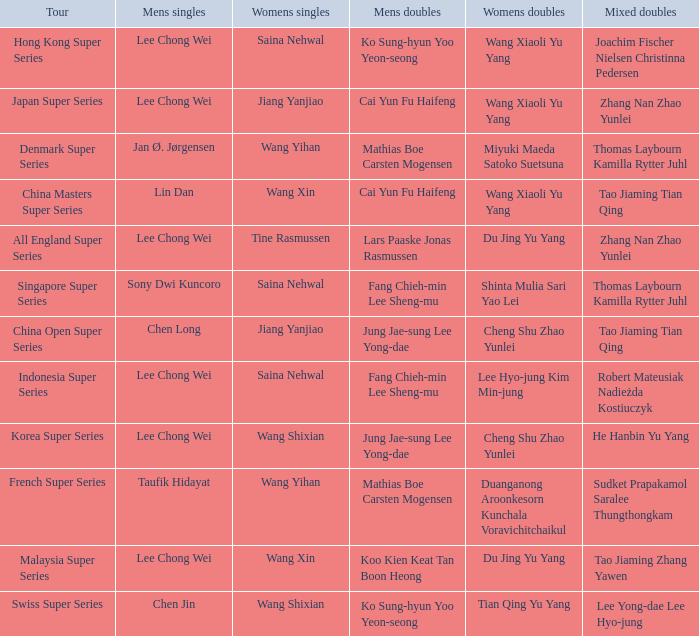Would you be able to parse every entry in this table? {'header': ['Tour', 'Mens singles', 'Womens singles', 'Mens doubles', 'Womens doubles', 'Mixed doubles'], 'rows': [['Hong Kong Super Series', 'Lee Chong Wei', 'Saina Nehwal', 'Ko Sung-hyun Yoo Yeon-seong', 'Wang Xiaoli Yu Yang', 'Joachim Fischer Nielsen Christinna Pedersen'], ['Japan Super Series', 'Lee Chong Wei', 'Jiang Yanjiao', 'Cai Yun Fu Haifeng', 'Wang Xiaoli Yu Yang', 'Zhang Nan Zhao Yunlei'], ['Denmark Super Series', 'Jan Ø. Jørgensen', 'Wang Yihan', 'Mathias Boe Carsten Mogensen', 'Miyuki Maeda Satoko Suetsuna', 'Thomas Laybourn Kamilla Rytter Juhl'], ['China Masters Super Series', 'Lin Dan', 'Wang Xin', 'Cai Yun Fu Haifeng', 'Wang Xiaoli Yu Yang', 'Tao Jiaming Tian Qing'], ['All England Super Series', 'Lee Chong Wei', 'Tine Rasmussen', 'Lars Paaske Jonas Rasmussen', 'Du Jing Yu Yang', 'Zhang Nan Zhao Yunlei'], ['Singapore Super Series', 'Sony Dwi Kuncoro', 'Saina Nehwal', 'Fang Chieh-min Lee Sheng-mu', 'Shinta Mulia Sari Yao Lei', 'Thomas Laybourn Kamilla Rytter Juhl'], ['China Open Super Series', 'Chen Long', 'Jiang Yanjiao', 'Jung Jae-sung Lee Yong-dae', 'Cheng Shu Zhao Yunlei', 'Tao Jiaming Tian Qing'], ['Indonesia Super Series', 'Lee Chong Wei', 'Saina Nehwal', 'Fang Chieh-min Lee Sheng-mu', 'Lee Hyo-jung Kim Min-jung', 'Robert Mateusiak Nadieżda Kostiuczyk'], ['Korea Super Series', 'Lee Chong Wei', 'Wang Shixian', 'Jung Jae-sung Lee Yong-dae', 'Cheng Shu Zhao Yunlei', 'He Hanbin Yu Yang'], ['French Super Series', 'Taufik Hidayat', 'Wang Yihan', 'Mathias Boe Carsten Mogensen', 'Duanganong Aroonkesorn Kunchala Voravichitchaikul', 'Sudket Prapakamol Saralee Thungthongkam'], ['Malaysia Super Series', 'Lee Chong Wei', 'Wang Xin', 'Koo Kien Keat Tan Boon Heong', 'Du Jing Yu Yang', 'Tao Jiaming Zhang Yawen'], ['Swiss Super Series', 'Chen Jin', 'Wang Shixian', 'Ko Sung-hyun Yoo Yeon-seong', 'Tian Qing Yu Yang', 'Lee Yong-dae Lee Hyo-jung']]} Who is the womens doubles on the tour french super series? Duanganong Aroonkesorn Kunchala Voravichitchaikul. 